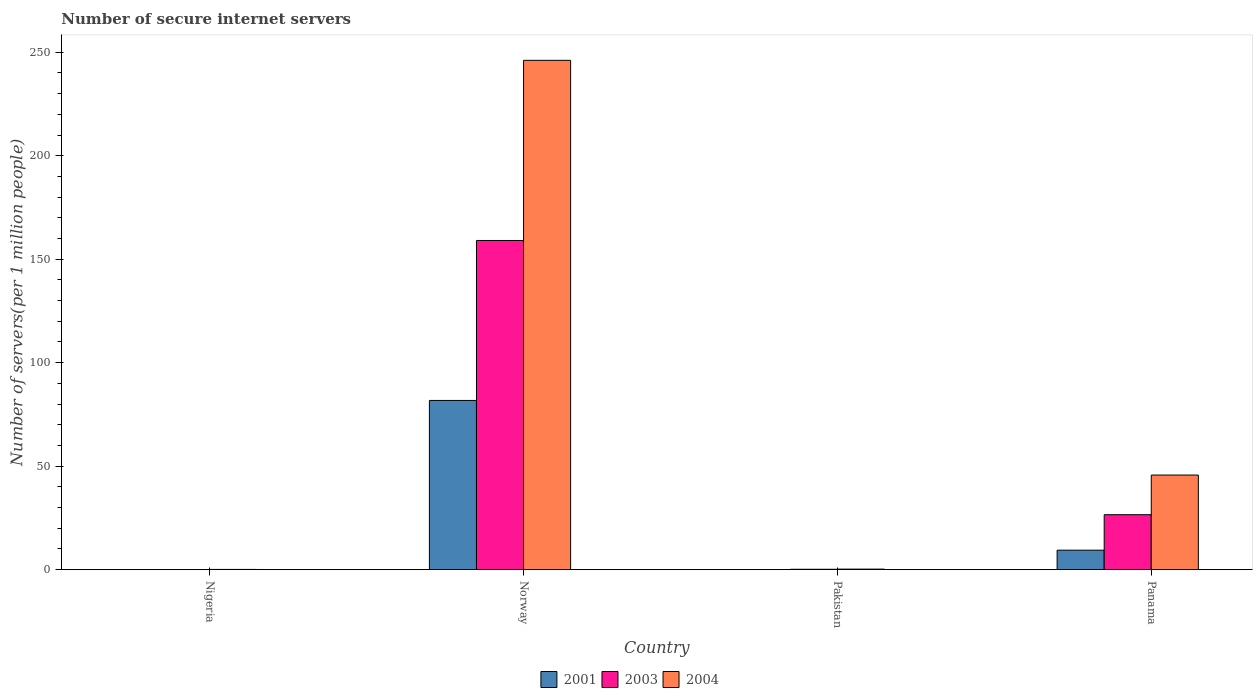Are the number of bars per tick equal to the number of legend labels?
Offer a very short reply. Yes. What is the label of the 1st group of bars from the left?
Keep it short and to the point. Nigeria. What is the number of secure internet servers in 2003 in Panama?
Keep it short and to the point. 26.54. Across all countries, what is the maximum number of secure internet servers in 2004?
Offer a very short reply. 246.08. Across all countries, what is the minimum number of secure internet servers in 2004?
Offer a terse response. 0.1. In which country was the number of secure internet servers in 2004 maximum?
Offer a terse response. Norway. In which country was the number of secure internet servers in 2001 minimum?
Make the answer very short. Nigeria. What is the total number of secure internet servers in 2004 in the graph?
Offer a very short reply. 292.12. What is the difference between the number of secure internet servers in 2003 in Nigeria and that in Pakistan?
Give a very brief answer. -0.15. What is the difference between the number of secure internet servers in 2003 in Nigeria and the number of secure internet servers in 2001 in Pakistan?
Your response must be concise. -0.02. What is the average number of secure internet servers in 2003 per country?
Give a very brief answer. 46.44. What is the difference between the number of secure internet servers of/in 2004 and number of secure internet servers of/in 2003 in Nigeria?
Your answer should be very brief. 0.07. What is the ratio of the number of secure internet servers in 2004 in Norway to that in Panama?
Your response must be concise. 5.39. Is the number of secure internet servers in 2003 in Nigeria less than that in Pakistan?
Provide a short and direct response. Yes. What is the difference between the highest and the second highest number of secure internet servers in 2003?
Your answer should be compact. -26.37. What is the difference between the highest and the lowest number of secure internet servers in 2004?
Keep it short and to the point. 245.99. In how many countries, is the number of secure internet servers in 2001 greater than the average number of secure internet servers in 2001 taken over all countries?
Your answer should be compact. 1. What does the 2nd bar from the right in Norway represents?
Offer a terse response. 2003. Is it the case that in every country, the sum of the number of secure internet servers in 2003 and number of secure internet servers in 2004 is greater than the number of secure internet servers in 2001?
Your answer should be compact. Yes. How many countries are there in the graph?
Provide a short and direct response. 4. What is the difference between two consecutive major ticks on the Y-axis?
Keep it short and to the point. 50. Does the graph contain any zero values?
Give a very brief answer. No. Where does the legend appear in the graph?
Your response must be concise. Bottom center. How many legend labels are there?
Your answer should be very brief. 3. How are the legend labels stacked?
Provide a short and direct response. Horizontal. What is the title of the graph?
Offer a very short reply. Number of secure internet servers. What is the label or title of the Y-axis?
Give a very brief answer. Number of servers(per 1 million people). What is the Number of servers(per 1 million people) of 2001 in Nigeria?
Keep it short and to the point. 0.01. What is the Number of servers(per 1 million people) in 2003 in Nigeria?
Offer a terse response. 0.02. What is the Number of servers(per 1 million people) of 2004 in Nigeria?
Keep it short and to the point. 0.1. What is the Number of servers(per 1 million people) of 2001 in Norway?
Give a very brief answer. 81.75. What is the Number of servers(per 1 million people) in 2003 in Norway?
Give a very brief answer. 159.04. What is the Number of servers(per 1 million people) in 2004 in Norway?
Ensure brevity in your answer.  246.08. What is the Number of servers(per 1 million people) in 2001 in Pakistan?
Ensure brevity in your answer.  0.04. What is the Number of servers(per 1 million people) of 2003 in Pakistan?
Offer a terse response. 0.17. What is the Number of servers(per 1 million people) in 2004 in Pakistan?
Make the answer very short. 0.25. What is the Number of servers(per 1 million people) of 2001 in Panama?
Make the answer very short. 9.39. What is the Number of servers(per 1 million people) in 2003 in Panama?
Offer a very short reply. 26.54. What is the Number of servers(per 1 million people) of 2004 in Panama?
Provide a succinct answer. 45.7. Across all countries, what is the maximum Number of servers(per 1 million people) in 2001?
Make the answer very short. 81.75. Across all countries, what is the maximum Number of servers(per 1 million people) of 2003?
Make the answer very short. 159.04. Across all countries, what is the maximum Number of servers(per 1 million people) of 2004?
Your answer should be compact. 246.08. Across all countries, what is the minimum Number of servers(per 1 million people) in 2001?
Your answer should be very brief. 0.01. Across all countries, what is the minimum Number of servers(per 1 million people) of 2003?
Keep it short and to the point. 0.02. Across all countries, what is the minimum Number of servers(per 1 million people) of 2004?
Offer a very short reply. 0.1. What is the total Number of servers(per 1 million people) in 2001 in the graph?
Your response must be concise. 91.2. What is the total Number of servers(per 1 million people) in 2003 in the graph?
Ensure brevity in your answer.  185.78. What is the total Number of servers(per 1 million people) in 2004 in the graph?
Provide a succinct answer. 292.12. What is the difference between the Number of servers(per 1 million people) in 2001 in Nigeria and that in Norway?
Your response must be concise. -81.74. What is the difference between the Number of servers(per 1 million people) in 2003 in Nigeria and that in Norway?
Offer a terse response. -159.02. What is the difference between the Number of servers(per 1 million people) in 2004 in Nigeria and that in Norway?
Provide a short and direct response. -245.99. What is the difference between the Number of servers(per 1 million people) of 2001 in Nigeria and that in Pakistan?
Make the answer very short. -0.03. What is the difference between the Number of servers(per 1 million people) in 2003 in Nigeria and that in Pakistan?
Keep it short and to the point. -0.15. What is the difference between the Number of servers(per 1 million people) of 2004 in Nigeria and that in Pakistan?
Offer a very short reply. -0.15. What is the difference between the Number of servers(per 1 million people) of 2001 in Nigeria and that in Panama?
Keep it short and to the point. -9.39. What is the difference between the Number of servers(per 1 million people) of 2003 in Nigeria and that in Panama?
Your response must be concise. -26.52. What is the difference between the Number of servers(per 1 million people) in 2004 in Nigeria and that in Panama?
Make the answer very short. -45.6. What is the difference between the Number of servers(per 1 million people) of 2001 in Norway and that in Pakistan?
Provide a short and direct response. 81.71. What is the difference between the Number of servers(per 1 million people) in 2003 in Norway and that in Pakistan?
Your response must be concise. 158.87. What is the difference between the Number of servers(per 1 million people) of 2004 in Norway and that in Pakistan?
Your answer should be compact. 245.84. What is the difference between the Number of servers(per 1 million people) of 2001 in Norway and that in Panama?
Your answer should be very brief. 72.36. What is the difference between the Number of servers(per 1 million people) of 2003 in Norway and that in Panama?
Provide a succinct answer. 132.5. What is the difference between the Number of servers(per 1 million people) of 2004 in Norway and that in Panama?
Make the answer very short. 200.39. What is the difference between the Number of servers(per 1 million people) in 2001 in Pakistan and that in Panama?
Provide a succinct answer. -9.35. What is the difference between the Number of servers(per 1 million people) of 2003 in Pakistan and that in Panama?
Give a very brief answer. -26.37. What is the difference between the Number of servers(per 1 million people) in 2004 in Pakistan and that in Panama?
Provide a short and direct response. -45.45. What is the difference between the Number of servers(per 1 million people) of 2001 in Nigeria and the Number of servers(per 1 million people) of 2003 in Norway?
Provide a short and direct response. -159.03. What is the difference between the Number of servers(per 1 million people) in 2001 in Nigeria and the Number of servers(per 1 million people) in 2004 in Norway?
Keep it short and to the point. -246.08. What is the difference between the Number of servers(per 1 million people) of 2003 in Nigeria and the Number of servers(per 1 million people) of 2004 in Norway?
Keep it short and to the point. -246.06. What is the difference between the Number of servers(per 1 million people) in 2001 in Nigeria and the Number of servers(per 1 million people) in 2003 in Pakistan?
Ensure brevity in your answer.  -0.16. What is the difference between the Number of servers(per 1 million people) of 2001 in Nigeria and the Number of servers(per 1 million people) of 2004 in Pakistan?
Your response must be concise. -0.24. What is the difference between the Number of servers(per 1 million people) in 2003 in Nigeria and the Number of servers(per 1 million people) in 2004 in Pakistan?
Give a very brief answer. -0.22. What is the difference between the Number of servers(per 1 million people) in 2001 in Nigeria and the Number of servers(per 1 million people) in 2003 in Panama?
Make the answer very short. -26.53. What is the difference between the Number of servers(per 1 million people) in 2001 in Nigeria and the Number of servers(per 1 million people) in 2004 in Panama?
Your answer should be very brief. -45.69. What is the difference between the Number of servers(per 1 million people) of 2003 in Nigeria and the Number of servers(per 1 million people) of 2004 in Panama?
Offer a very short reply. -45.67. What is the difference between the Number of servers(per 1 million people) of 2001 in Norway and the Number of servers(per 1 million people) of 2003 in Pakistan?
Your answer should be very brief. 81.58. What is the difference between the Number of servers(per 1 million people) of 2001 in Norway and the Number of servers(per 1 million people) of 2004 in Pakistan?
Give a very brief answer. 81.5. What is the difference between the Number of servers(per 1 million people) of 2003 in Norway and the Number of servers(per 1 million people) of 2004 in Pakistan?
Keep it short and to the point. 158.79. What is the difference between the Number of servers(per 1 million people) of 2001 in Norway and the Number of servers(per 1 million people) of 2003 in Panama?
Your response must be concise. 55.21. What is the difference between the Number of servers(per 1 million people) of 2001 in Norway and the Number of servers(per 1 million people) of 2004 in Panama?
Your answer should be very brief. 36.05. What is the difference between the Number of servers(per 1 million people) in 2003 in Norway and the Number of servers(per 1 million people) in 2004 in Panama?
Your answer should be very brief. 113.34. What is the difference between the Number of servers(per 1 million people) in 2001 in Pakistan and the Number of servers(per 1 million people) in 2003 in Panama?
Your answer should be very brief. -26.5. What is the difference between the Number of servers(per 1 million people) in 2001 in Pakistan and the Number of servers(per 1 million people) in 2004 in Panama?
Offer a very short reply. -45.65. What is the difference between the Number of servers(per 1 million people) of 2003 in Pakistan and the Number of servers(per 1 million people) of 2004 in Panama?
Provide a short and direct response. -45.53. What is the average Number of servers(per 1 million people) in 2001 per country?
Give a very brief answer. 22.8. What is the average Number of servers(per 1 million people) in 2003 per country?
Offer a very short reply. 46.44. What is the average Number of servers(per 1 million people) in 2004 per country?
Offer a terse response. 73.03. What is the difference between the Number of servers(per 1 million people) in 2001 and Number of servers(per 1 million people) in 2003 in Nigeria?
Give a very brief answer. -0.01. What is the difference between the Number of servers(per 1 million people) in 2001 and Number of servers(per 1 million people) in 2004 in Nigeria?
Your response must be concise. -0.09. What is the difference between the Number of servers(per 1 million people) of 2003 and Number of servers(per 1 million people) of 2004 in Nigeria?
Make the answer very short. -0.07. What is the difference between the Number of servers(per 1 million people) of 2001 and Number of servers(per 1 million people) of 2003 in Norway?
Make the answer very short. -77.29. What is the difference between the Number of servers(per 1 million people) of 2001 and Number of servers(per 1 million people) of 2004 in Norway?
Your response must be concise. -164.33. What is the difference between the Number of servers(per 1 million people) in 2003 and Number of servers(per 1 million people) in 2004 in Norway?
Offer a terse response. -87.04. What is the difference between the Number of servers(per 1 million people) in 2001 and Number of servers(per 1 million people) in 2003 in Pakistan?
Offer a very short reply. -0.13. What is the difference between the Number of servers(per 1 million people) of 2001 and Number of servers(per 1 million people) of 2004 in Pakistan?
Keep it short and to the point. -0.2. What is the difference between the Number of servers(per 1 million people) in 2003 and Number of servers(per 1 million people) in 2004 in Pakistan?
Your answer should be compact. -0.08. What is the difference between the Number of servers(per 1 million people) in 2001 and Number of servers(per 1 million people) in 2003 in Panama?
Ensure brevity in your answer.  -17.15. What is the difference between the Number of servers(per 1 million people) of 2001 and Number of servers(per 1 million people) of 2004 in Panama?
Your answer should be compact. -36.3. What is the difference between the Number of servers(per 1 million people) in 2003 and Number of servers(per 1 million people) in 2004 in Panama?
Offer a very short reply. -19.16. What is the ratio of the Number of servers(per 1 million people) in 2001 in Nigeria to that in Norway?
Your response must be concise. 0. What is the ratio of the Number of servers(per 1 million people) of 2003 in Nigeria to that in Norway?
Provide a succinct answer. 0. What is the ratio of the Number of servers(per 1 million people) of 2004 in Nigeria to that in Norway?
Your answer should be compact. 0. What is the ratio of the Number of servers(per 1 million people) of 2001 in Nigeria to that in Pakistan?
Your response must be concise. 0.19. What is the ratio of the Number of servers(per 1 million people) in 2003 in Nigeria to that in Pakistan?
Provide a succinct answer. 0.13. What is the ratio of the Number of servers(per 1 million people) in 2004 in Nigeria to that in Pakistan?
Keep it short and to the point. 0.39. What is the ratio of the Number of servers(per 1 million people) in 2001 in Nigeria to that in Panama?
Provide a succinct answer. 0. What is the ratio of the Number of servers(per 1 million people) of 2003 in Nigeria to that in Panama?
Ensure brevity in your answer.  0. What is the ratio of the Number of servers(per 1 million people) in 2004 in Nigeria to that in Panama?
Provide a succinct answer. 0. What is the ratio of the Number of servers(per 1 million people) in 2001 in Norway to that in Pakistan?
Provide a short and direct response. 1924.97. What is the ratio of the Number of servers(per 1 million people) of 2003 in Norway to that in Pakistan?
Offer a terse response. 936.76. What is the ratio of the Number of servers(per 1 million people) of 2004 in Norway to that in Pakistan?
Give a very brief answer. 999.42. What is the ratio of the Number of servers(per 1 million people) of 2001 in Norway to that in Panama?
Your response must be concise. 8.7. What is the ratio of the Number of servers(per 1 million people) of 2003 in Norway to that in Panama?
Provide a short and direct response. 5.99. What is the ratio of the Number of servers(per 1 million people) in 2004 in Norway to that in Panama?
Keep it short and to the point. 5.39. What is the ratio of the Number of servers(per 1 million people) in 2001 in Pakistan to that in Panama?
Provide a succinct answer. 0. What is the ratio of the Number of servers(per 1 million people) of 2003 in Pakistan to that in Panama?
Keep it short and to the point. 0.01. What is the ratio of the Number of servers(per 1 million people) in 2004 in Pakistan to that in Panama?
Ensure brevity in your answer.  0.01. What is the difference between the highest and the second highest Number of servers(per 1 million people) of 2001?
Your answer should be compact. 72.36. What is the difference between the highest and the second highest Number of servers(per 1 million people) in 2003?
Give a very brief answer. 132.5. What is the difference between the highest and the second highest Number of servers(per 1 million people) of 2004?
Provide a short and direct response. 200.39. What is the difference between the highest and the lowest Number of servers(per 1 million people) of 2001?
Keep it short and to the point. 81.74. What is the difference between the highest and the lowest Number of servers(per 1 million people) of 2003?
Your answer should be very brief. 159.02. What is the difference between the highest and the lowest Number of servers(per 1 million people) in 2004?
Offer a terse response. 245.99. 